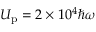<formula> <loc_0><loc_0><loc_500><loc_500>U _ { p } = 2 \times 1 0 ^ { 4 } \hbar { \omega }</formula> 